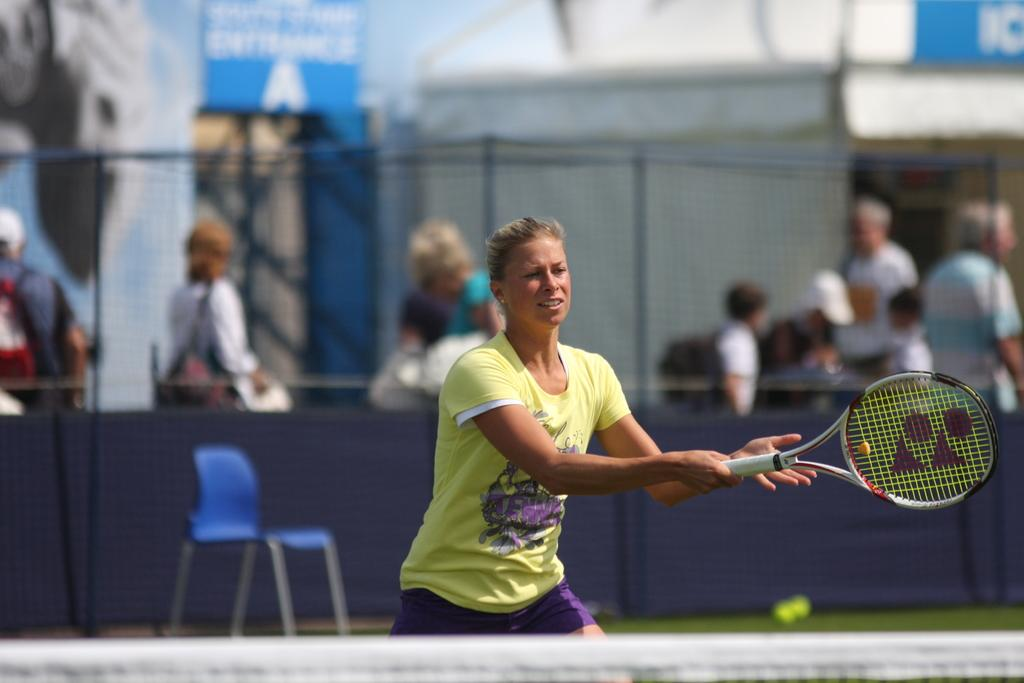What activity is the woman in the image engaged in? The woman is playing tennis in the image. Can you describe the people in the background of the image? There are people standing behind a fence in the image. What is the weather like in the image? The background of the image is cloudy. What type of spy equipment can be seen in the image? There is no spy equipment present in the image; it features a woman playing tennis and people standing behind a fence. 